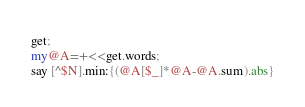Convert code to text. <code><loc_0><loc_0><loc_500><loc_500><_Perl_>get;
my@A=+<<get.words;
say [^$N].min:{(@A[$_]*@A-@A.sum).abs}
</code> 